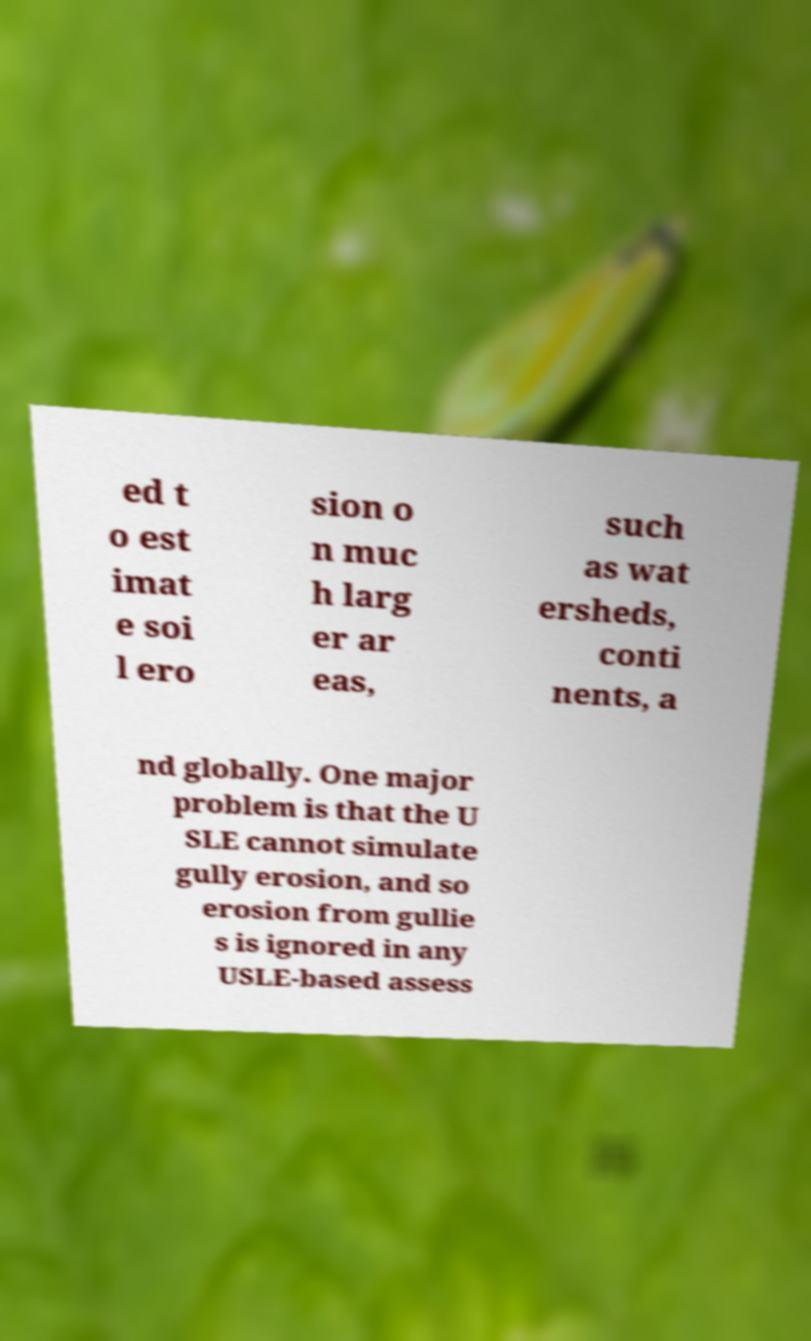I need the written content from this picture converted into text. Can you do that? ed t o est imat e soi l ero sion o n muc h larg er ar eas, such as wat ersheds, conti nents, a nd globally. One major problem is that the U SLE cannot simulate gully erosion, and so erosion from gullie s is ignored in any USLE-based assess 